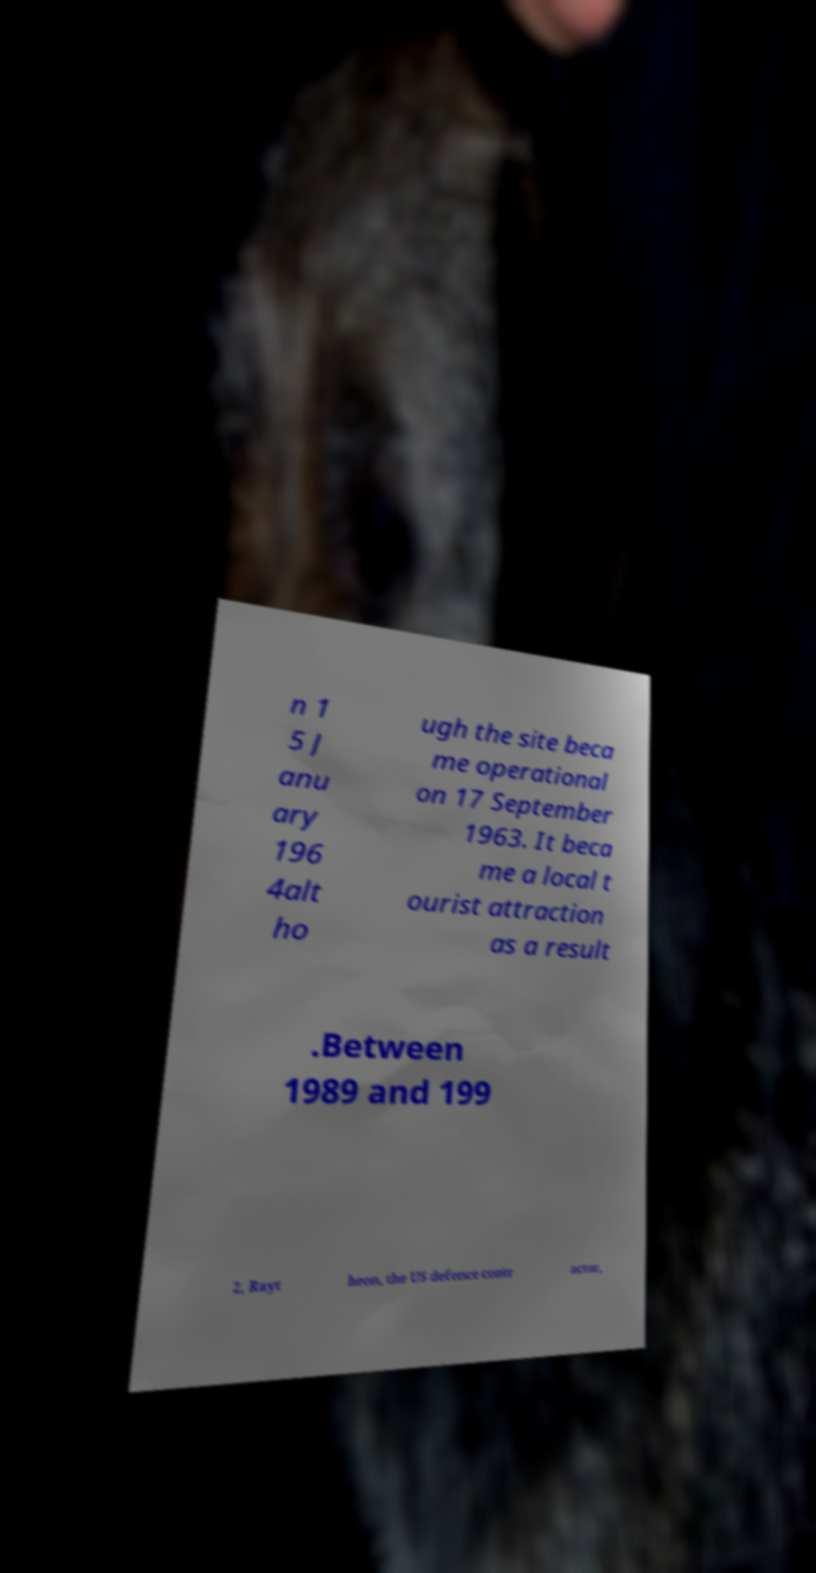Please identify and transcribe the text found in this image. n 1 5 J anu ary 196 4alt ho ugh the site beca me operational on 17 September 1963. It beca me a local t ourist attraction as a result .Between 1989 and 199 2, Rayt heon, the US defence contr actor, 